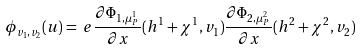<formula> <loc_0><loc_0><loc_500><loc_500>\phi _ { v _ { 1 } , v _ { 2 } } ( u ) & = \ e \frac { \partial \Phi _ { 1 , \mu _ { P } ^ { 1 } } } { \partial x } ( h ^ { 1 } + \chi ^ { 1 } , v _ { 1 } ) \frac { \partial \Phi _ { 2 , \mu _ { P } ^ { 2 } } } { \partial x } ( h ^ { 2 } + \chi ^ { 2 } , v _ { 2 } )</formula> 